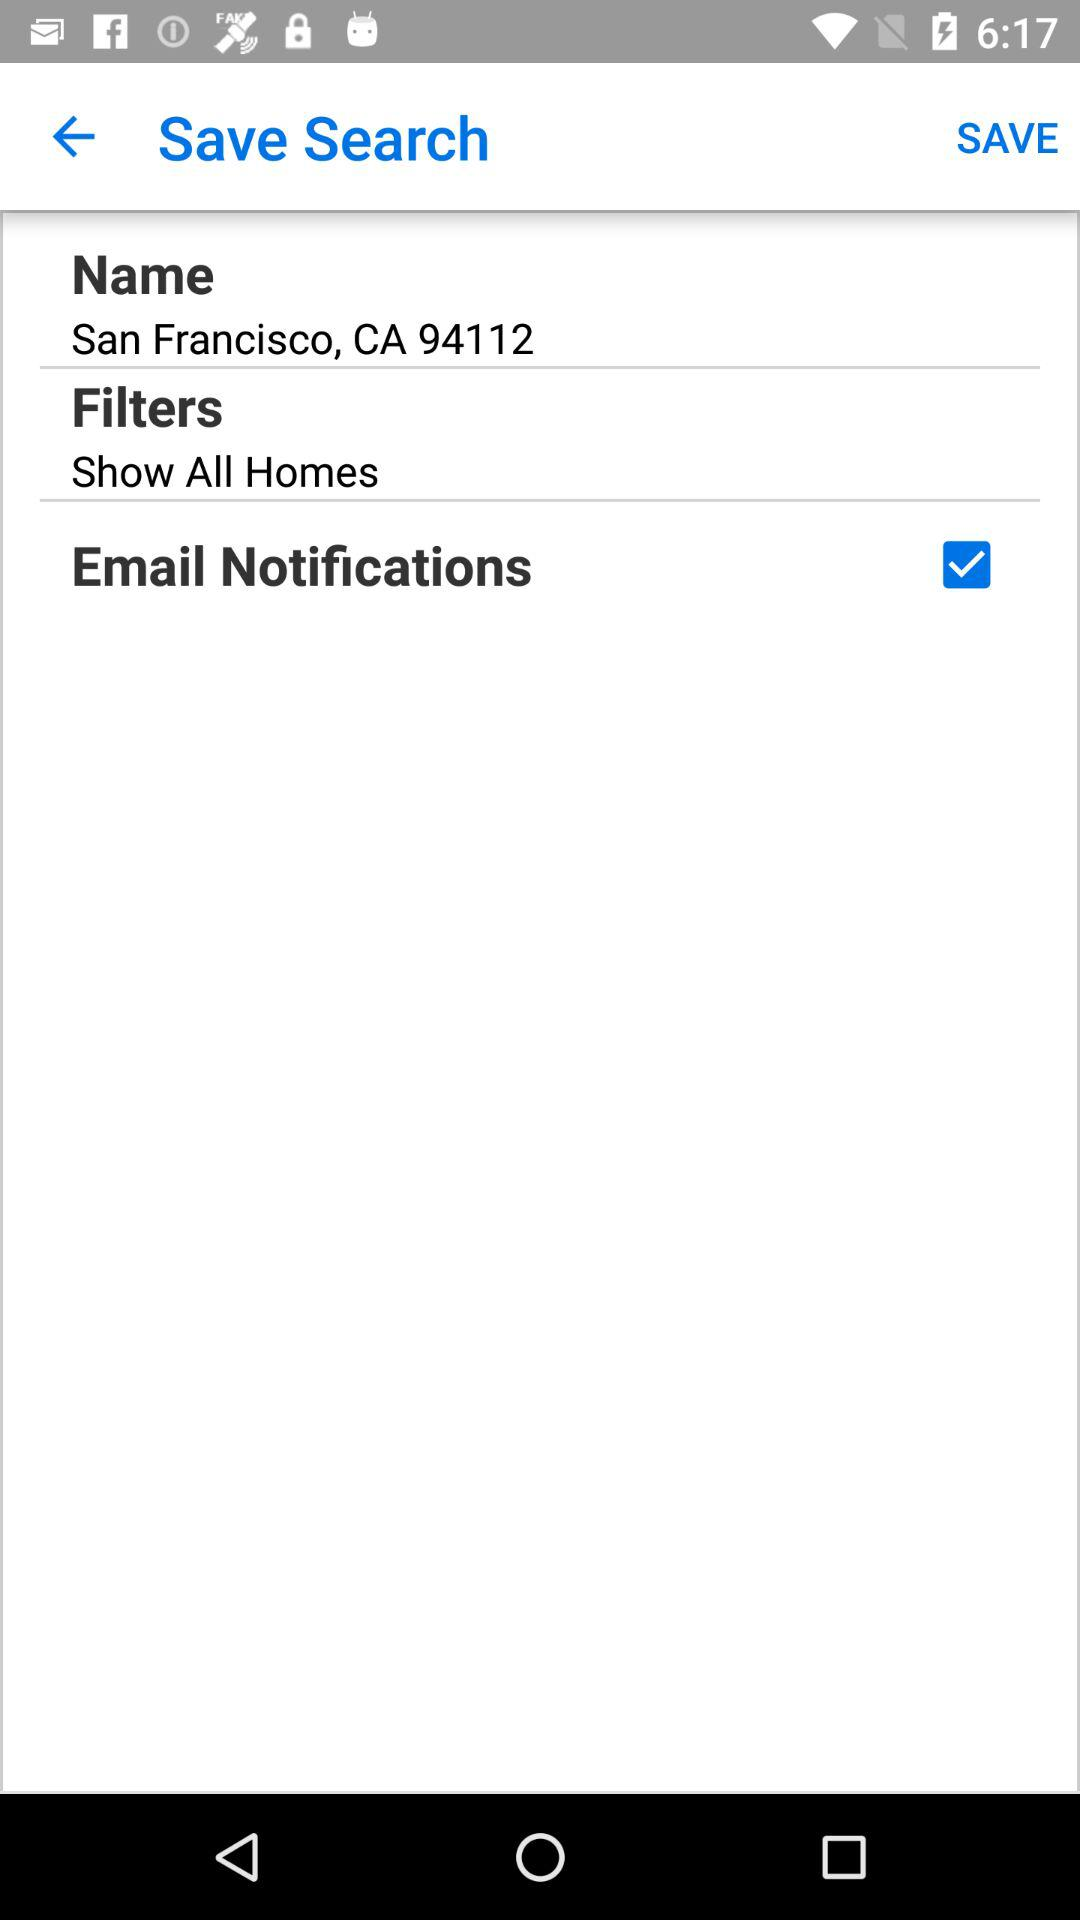What is the name of the user? The name of the user is San Francisco, CA 94112. 